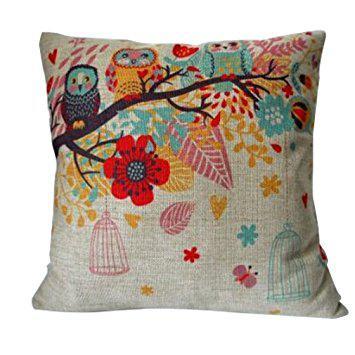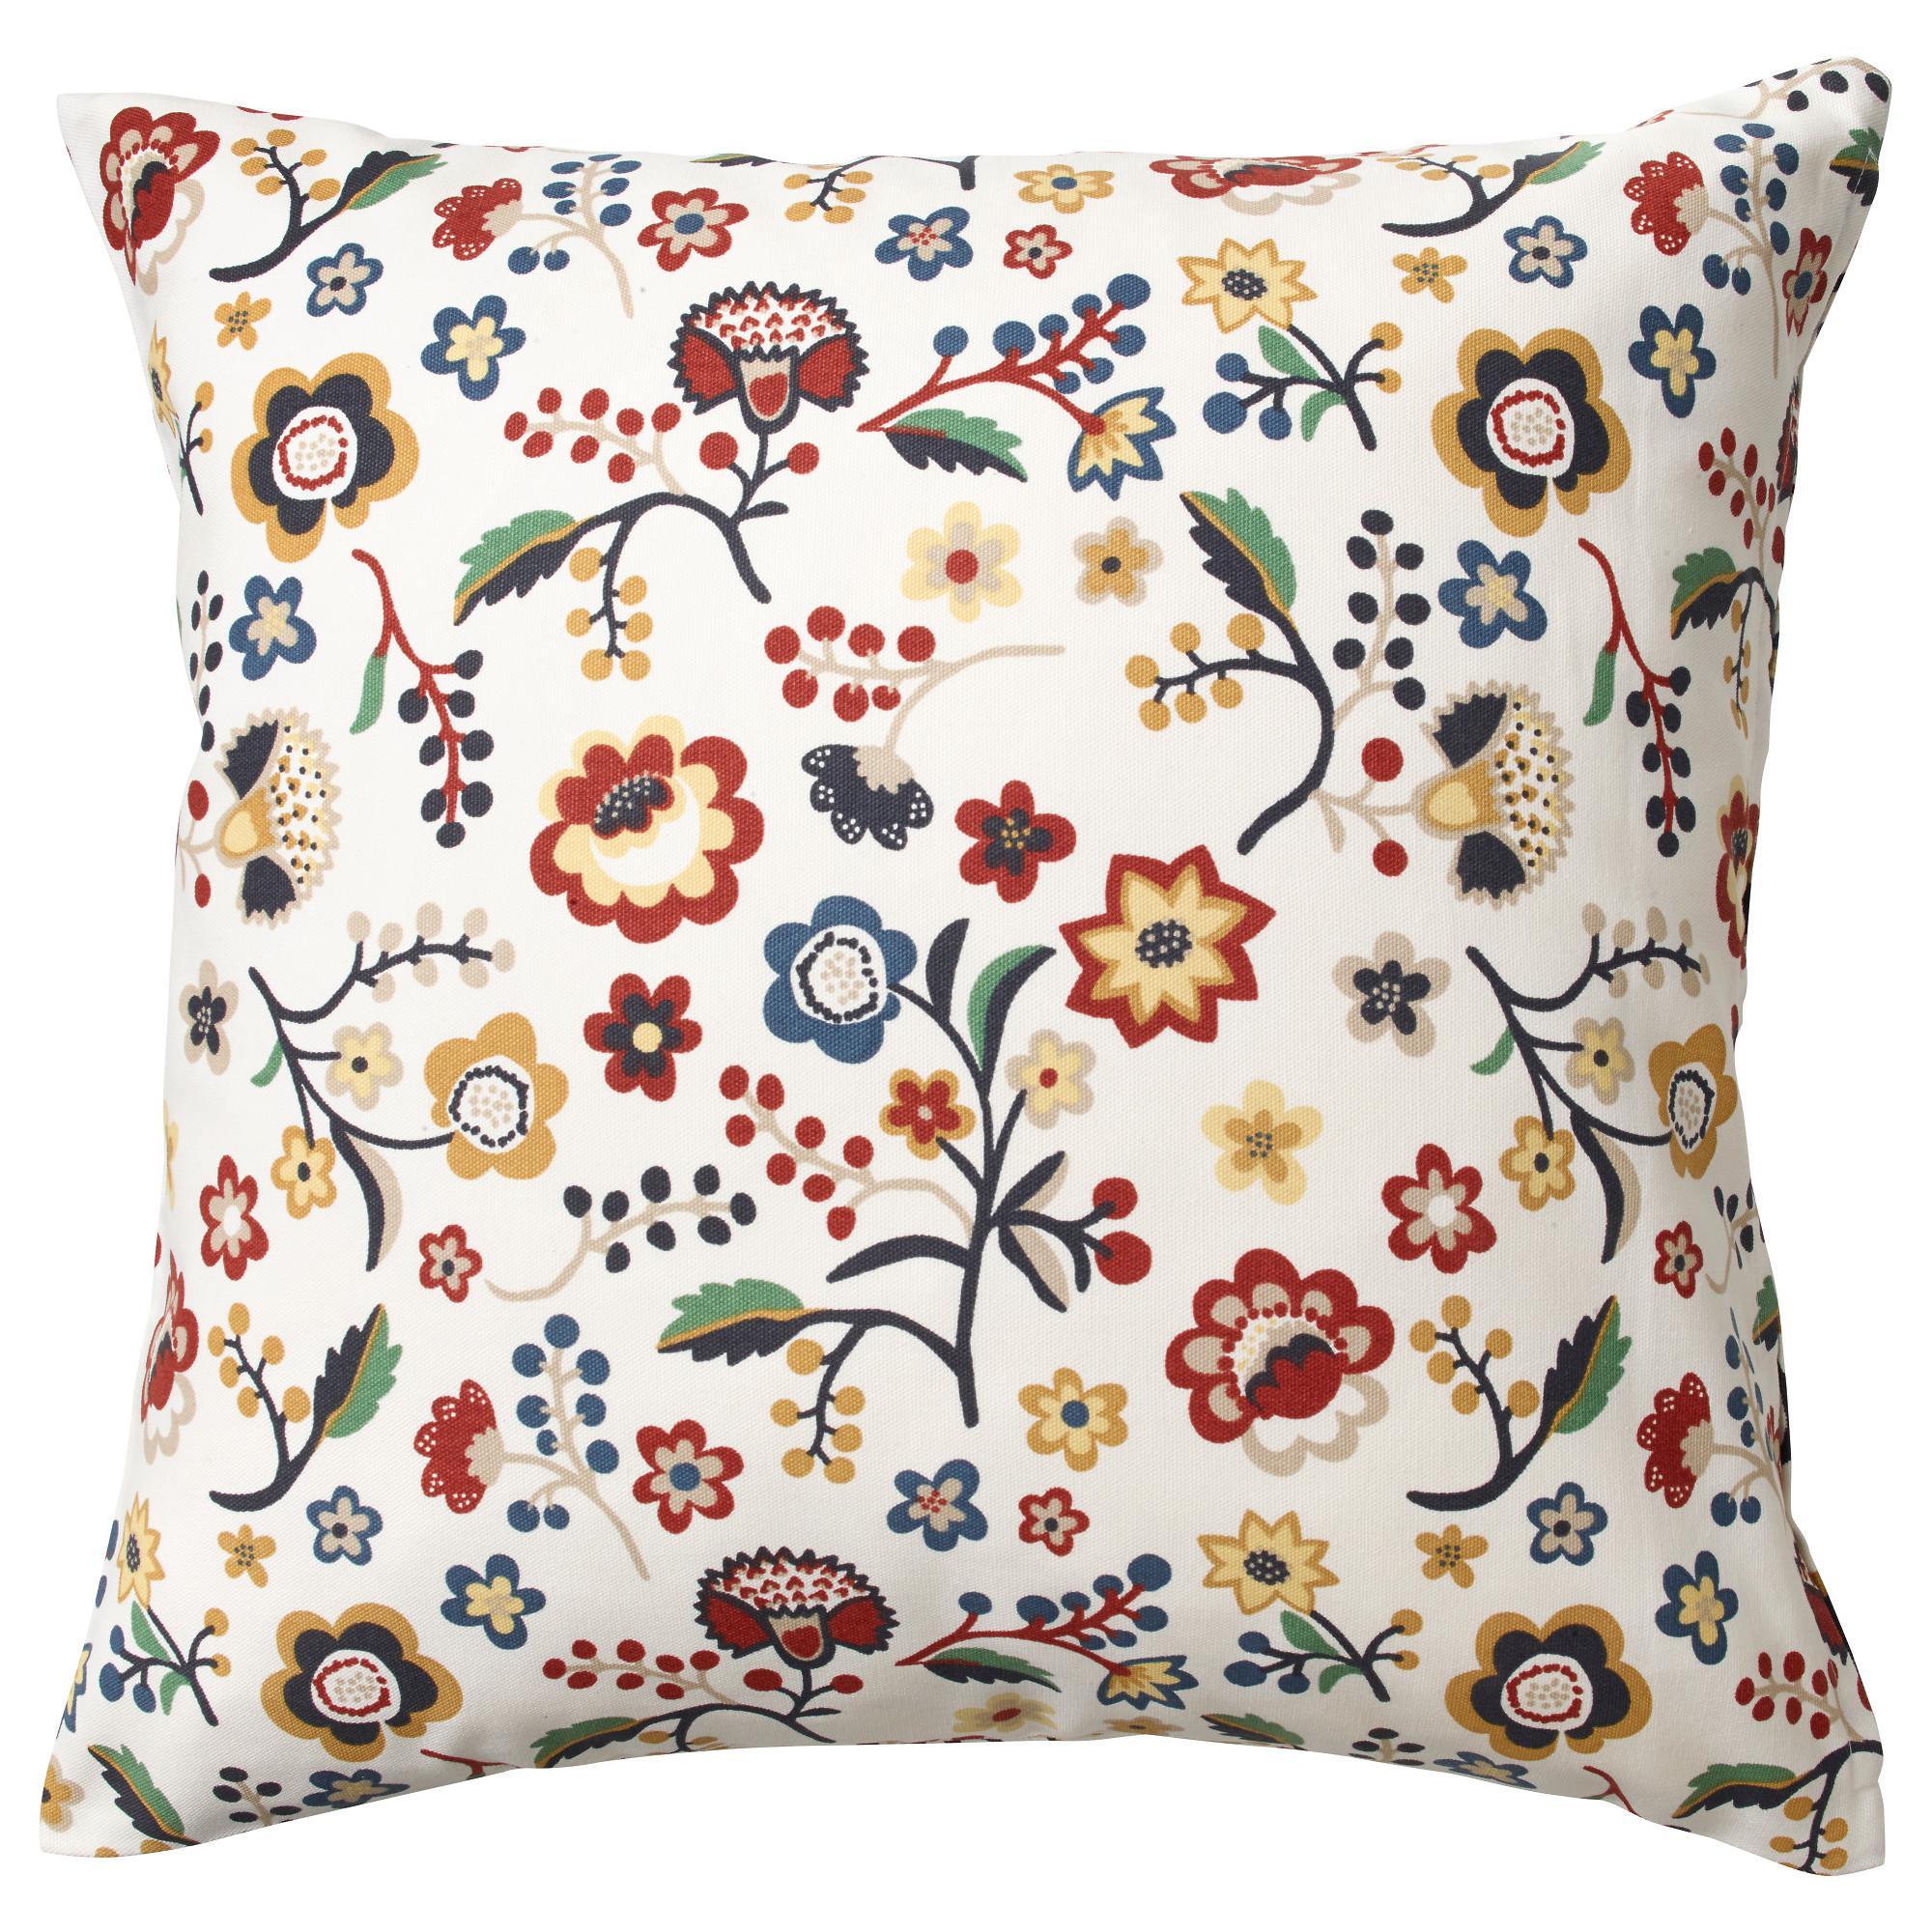The first image is the image on the left, the second image is the image on the right. Given the left and right images, does the statement "All of the pillows in one image feature multicolored birds on branches and have a pale neutral background color." hold true? Answer yes or no. Yes. The first image is the image on the left, the second image is the image on the right. Analyze the images presented: Is the assertion "The left image has exactly five pillows." valid? Answer yes or no. No. 